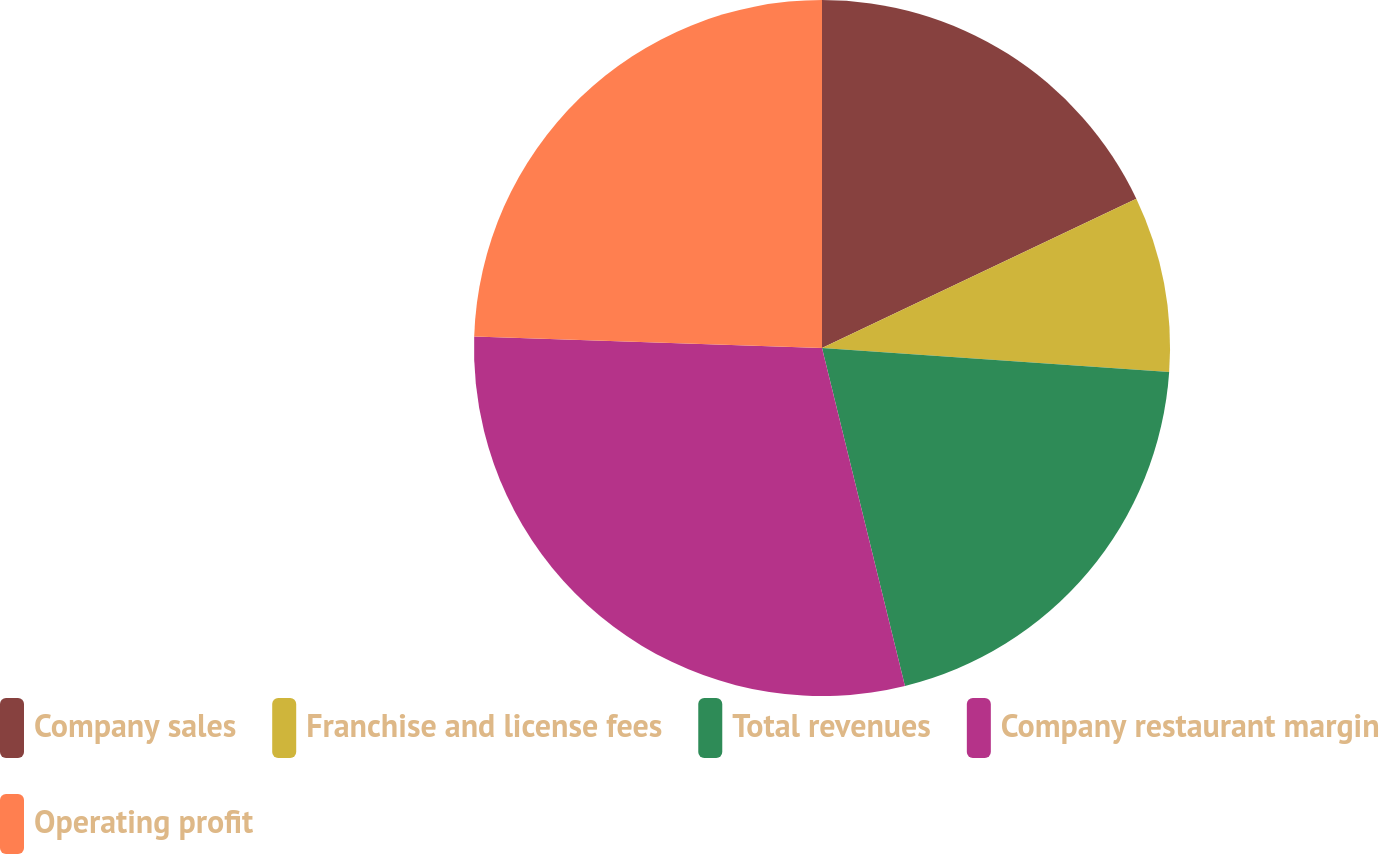Convert chart to OTSL. <chart><loc_0><loc_0><loc_500><loc_500><pie_chart><fcel>Company sales<fcel>Franchise and license fees<fcel>Total revenues<fcel>Company restaurant margin<fcel>Operating profit<nl><fcel>17.94%<fcel>8.16%<fcel>20.07%<fcel>29.36%<fcel>24.47%<nl></chart> 